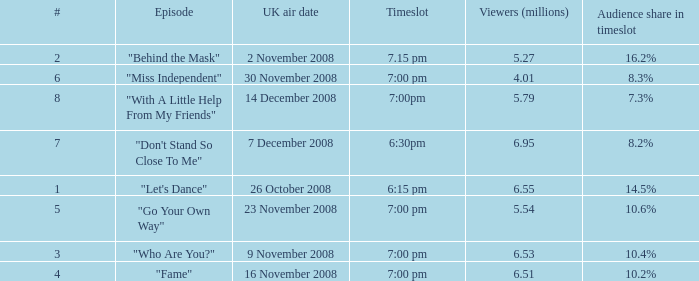Name the most number for viewers being 6.95 7.0. 